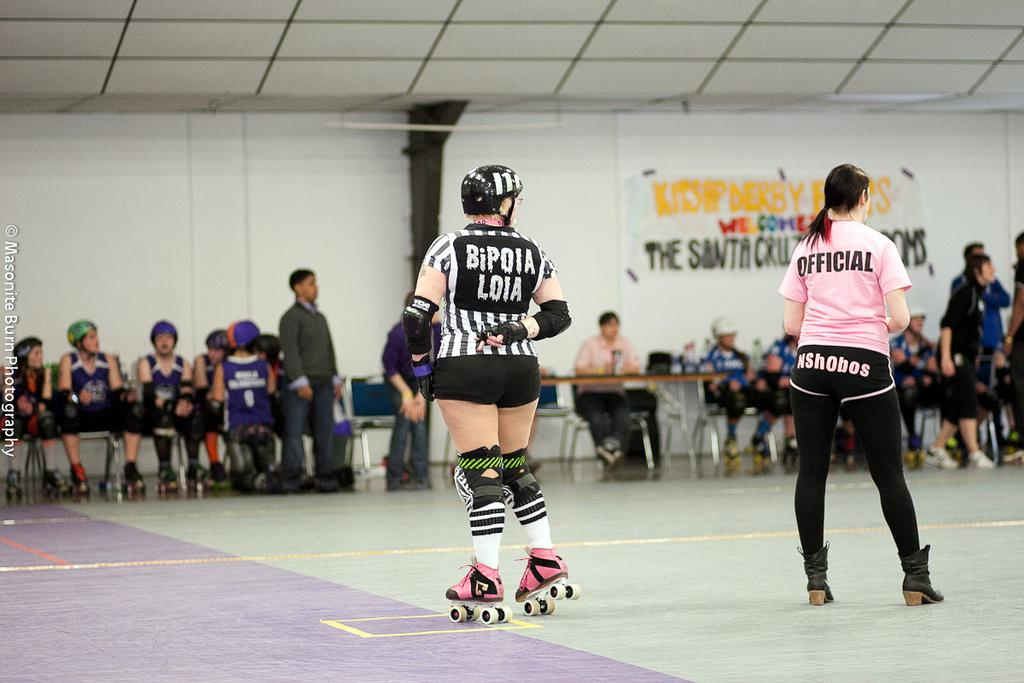What is the color of the wall in the image? The wall in the image is white. What can be seen hanging on the wall? There is a banner in the image. Who or what can be seen in the image besides the wall and banner? There are people, tables, and chairs visible in the image. What activity is one of the people engaged in? There is a person skating in the image. What is the aftermath of the person's knee injury while skating in the image? There is no indication of a knee injury or any aftermath in the image; the person is skating without any visible issues. 